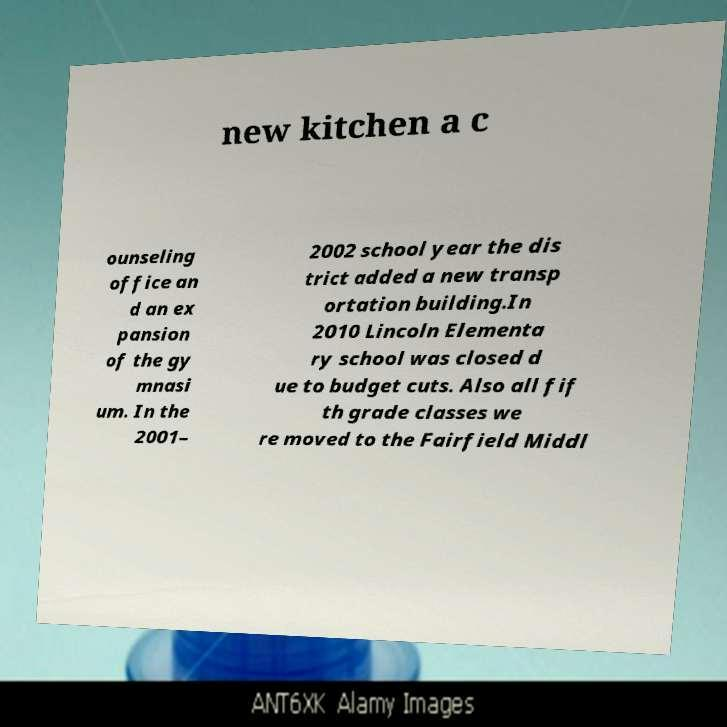Please identify and transcribe the text found in this image. new kitchen a c ounseling office an d an ex pansion of the gy mnasi um. In the 2001– 2002 school year the dis trict added a new transp ortation building.In 2010 Lincoln Elementa ry school was closed d ue to budget cuts. Also all fif th grade classes we re moved to the Fairfield Middl 